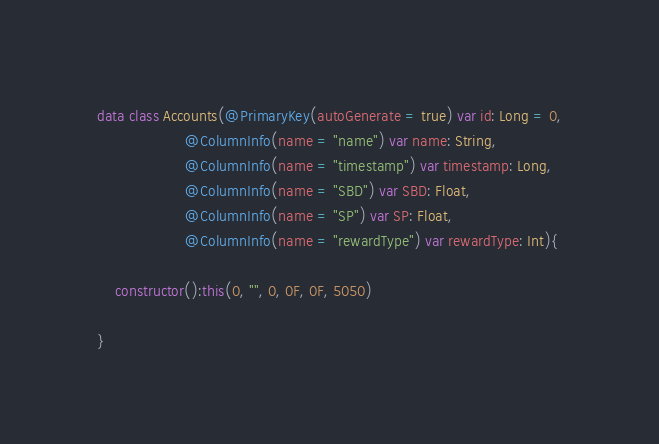Convert code to text. <code><loc_0><loc_0><loc_500><loc_500><_Kotlin_>data class Accounts(@PrimaryKey(autoGenerate = true) var id: Long = 0,
                    @ColumnInfo(name = "name") var name: String,
                    @ColumnInfo(name = "timestamp") var timestamp: Long,
                    @ColumnInfo(name = "SBD") var SBD: Float,
                    @ColumnInfo(name = "SP") var SP: Float,
                    @ColumnInfo(name = "rewardType") var rewardType: Int){

    constructor():this(0, "", 0, 0F, 0F, 5050)

}

</code> 